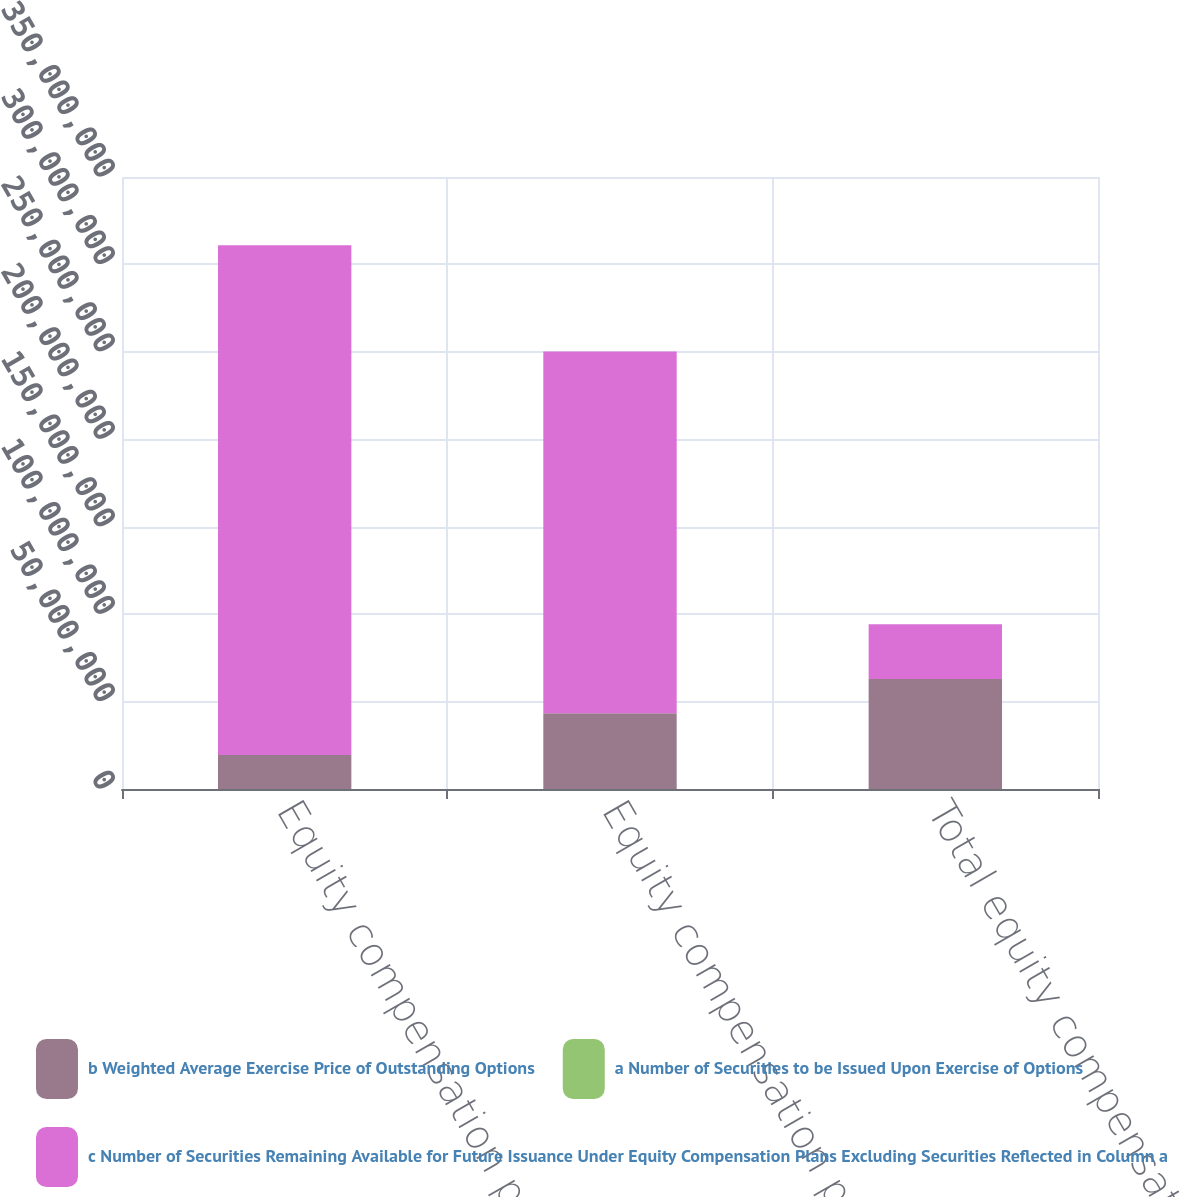Convert chart. <chart><loc_0><loc_0><loc_500><loc_500><stacked_bar_chart><ecel><fcel>Equity compensation plans<fcel>Equity compensation plans not<fcel>Total equity compensation<nl><fcel>b Weighted Average Exercise Price of Outstanding Options<fcel>1.95076e+07<fcel>4.33436e+07<fcel>6.28512e+07<nl><fcel>a Number of Securities to be Issued Upon Exercise of Options<fcel>18.75<fcel>19.29<fcel>19.12<nl><fcel>c Number of Securities Remaining Available for Future Issuance Under Equity Compensation Plans Excluding Securities Reflected in Column a<fcel>2.91429e+08<fcel>2.06892e+08<fcel>3.14256e+07<nl></chart> 